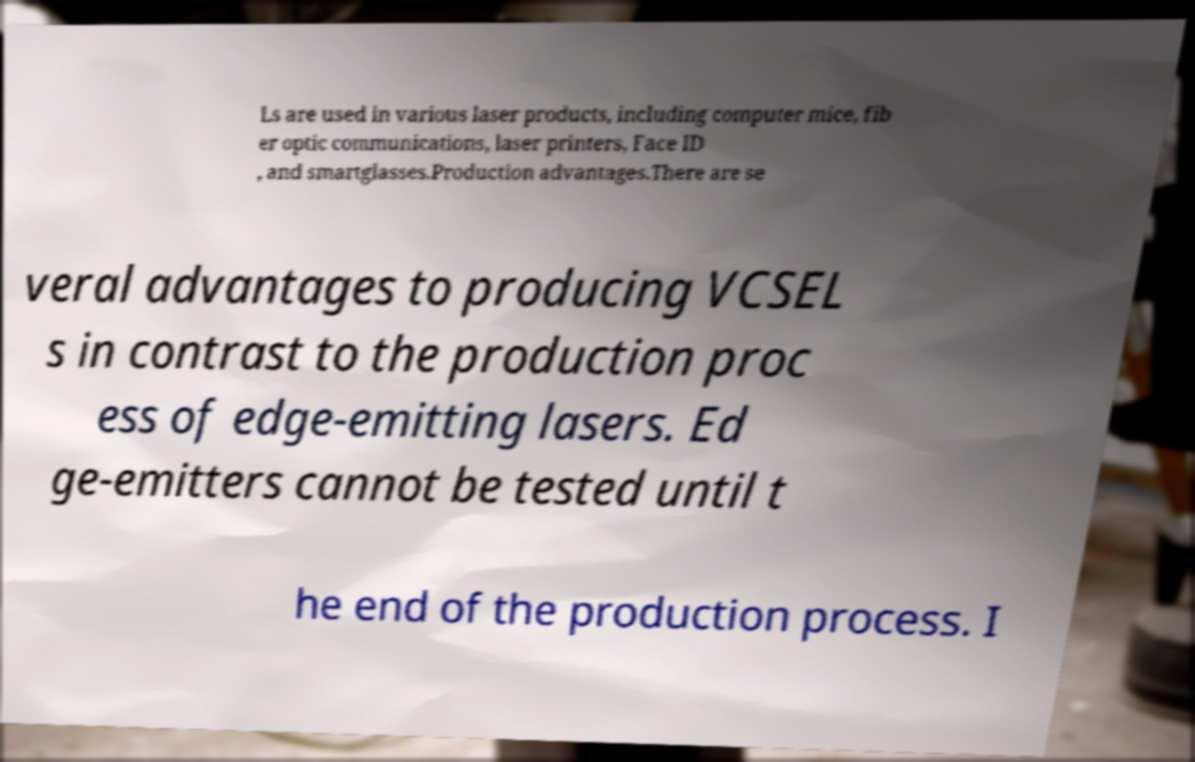Can you read and provide the text displayed in the image?This photo seems to have some interesting text. Can you extract and type it out for me? Ls are used in various laser products, including computer mice, fib er optic communications, laser printers, Face ID , and smartglasses.Production advantages.There are se veral advantages to producing VCSEL s in contrast to the production proc ess of edge-emitting lasers. Ed ge-emitters cannot be tested until t he end of the production process. I 